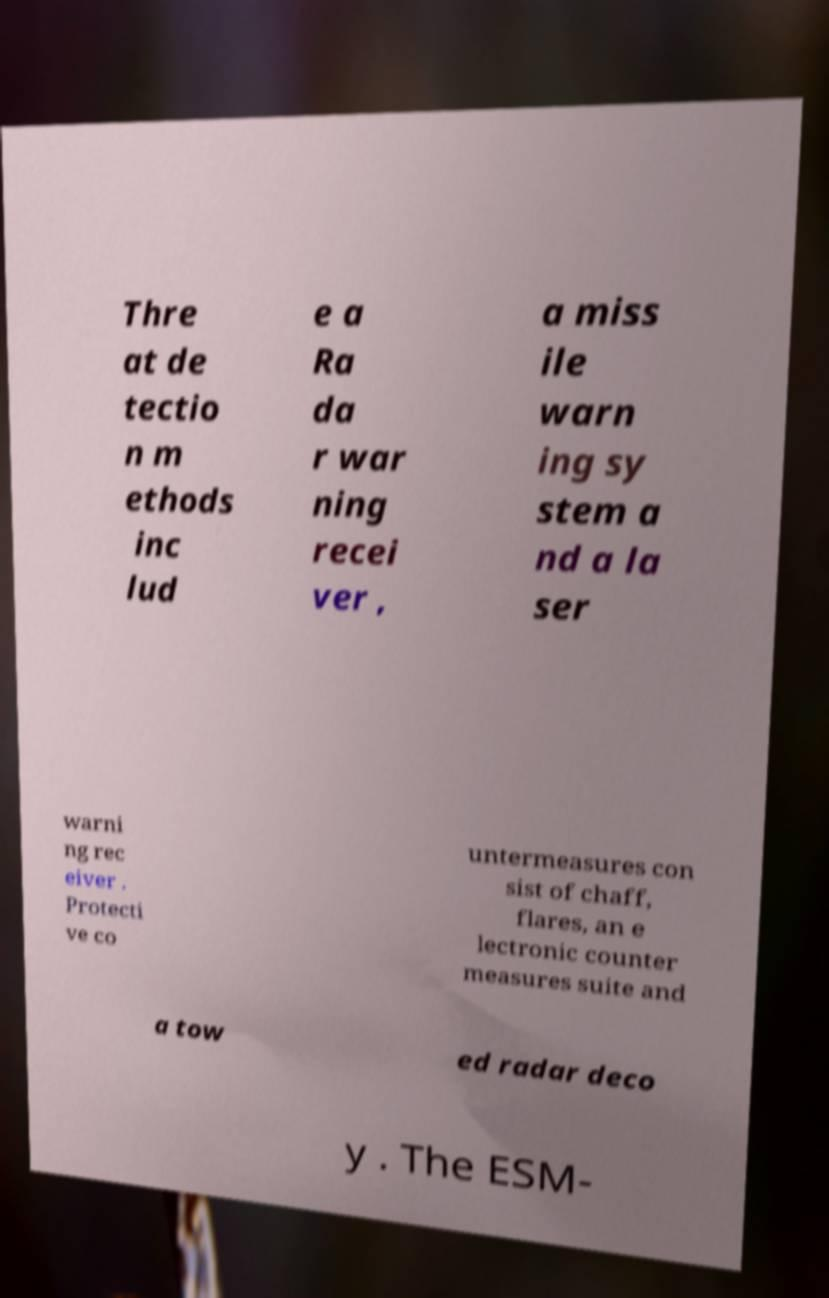Please read and relay the text visible in this image. What does it say? Thre at de tectio n m ethods inc lud e a Ra da r war ning recei ver , a miss ile warn ing sy stem a nd a la ser warni ng rec eiver . Protecti ve co untermeasures con sist of chaff, flares, an e lectronic counter measures suite and a tow ed radar deco y . The ESM- 